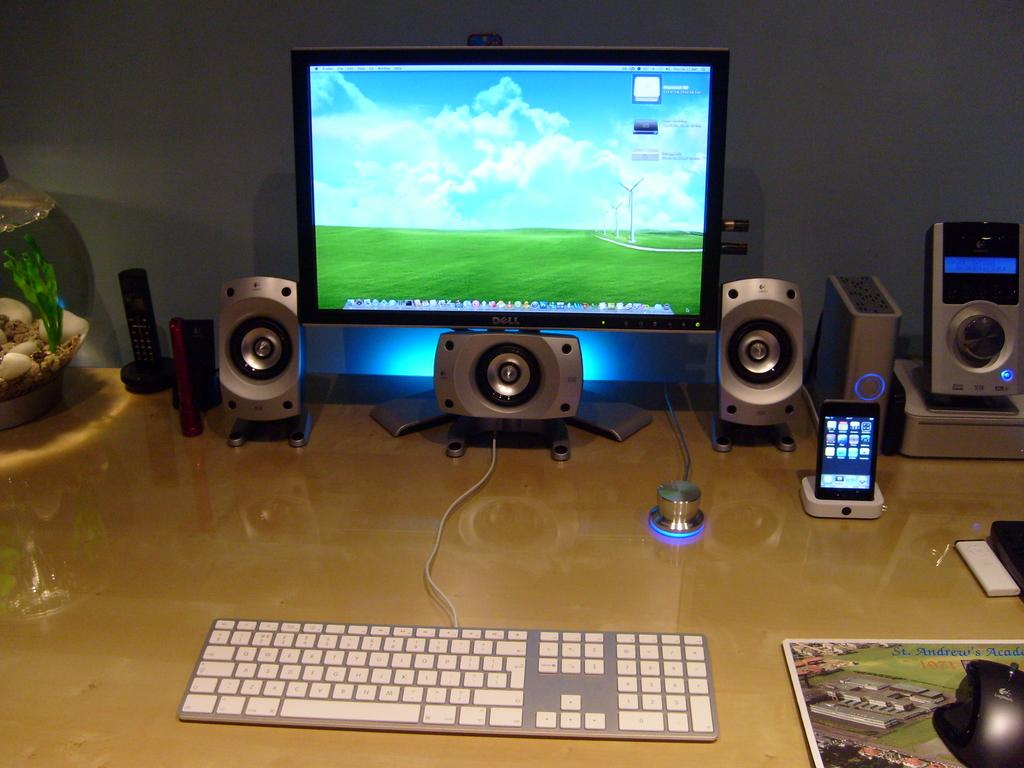What electronic device is located in the middle of the image? There is a monitor in the middle of the image. What is used for typing and inputting commands in the image? There is a keyboard in the image. What object is on the left side of the image? There is a water pot on the left side of the image. What type of stitch is being used to repair the monitor in the image? There is no stitching or repair work being done on the monitor in the image. How many trucks are visible in the image? There are no trucks present in the image. 